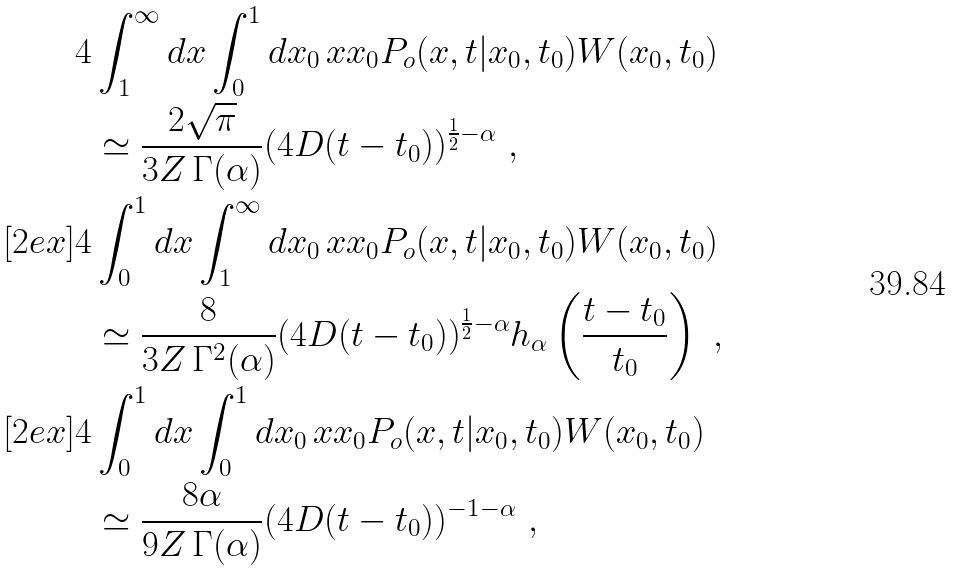Convert formula to latex. <formula><loc_0><loc_0><loc_500><loc_500>4 & \int _ { 1 } ^ { \infty } d x \int _ { 0 } ^ { 1 } d x _ { 0 } \, x x _ { 0 } P _ { o } ( x , t | x _ { 0 } , t _ { 0 } ) W ( x _ { 0 } , t _ { 0 } ) \\ & \simeq \frac { 2 \sqrt { \pi } } { 3 Z \, \Gamma ( \alpha ) } ( 4 D ( t - t _ { 0 } ) ) ^ { \frac { 1 } { 2 } - \alpha } \ , \\ [ 2 e x ] 4 & \int _ { 0 } ^ { 1 } d x \int _ { 1 } ^ { \infty } d x _ { 0 } \, x x _ { 0 } P _ { o } ( x , t | x _ { 0 } , t _ { 0 } ) W ( x _ { 0 } , t _ { 0 } ) \\ & \simeq \frac { 8 } { 3 Z \, \Gamma ^ { 2 } ( \alpha ) } ( 4 D ( t - t _ { 0 } ) ) ^ { \frac { 1 } { 2 } - \alpha } h _ { \alpha } \left ( \frac { t - t _ { 0 } } { t _ { 0 } } \right ) \ , \\ [ 2 e x ] 4 & \int _ { 0 } ^ { 1 } d x \int _ { 0 } ^ { 1 } d x _ { 0 } \, x x _ { 0 } P _ { o } ( x , t | x _ { 0 } , t _ { 0 } ) W ( x _ { 0 } , t _ { 0 } ) \\ & \simeq \frac { 8 \alpha } { 9 Z \, \Gamma ( \alpha ) } ( 4 D ( t - t _ { 0 } ) ) ^ { - 1 - \alpha } \ ,</formula> 